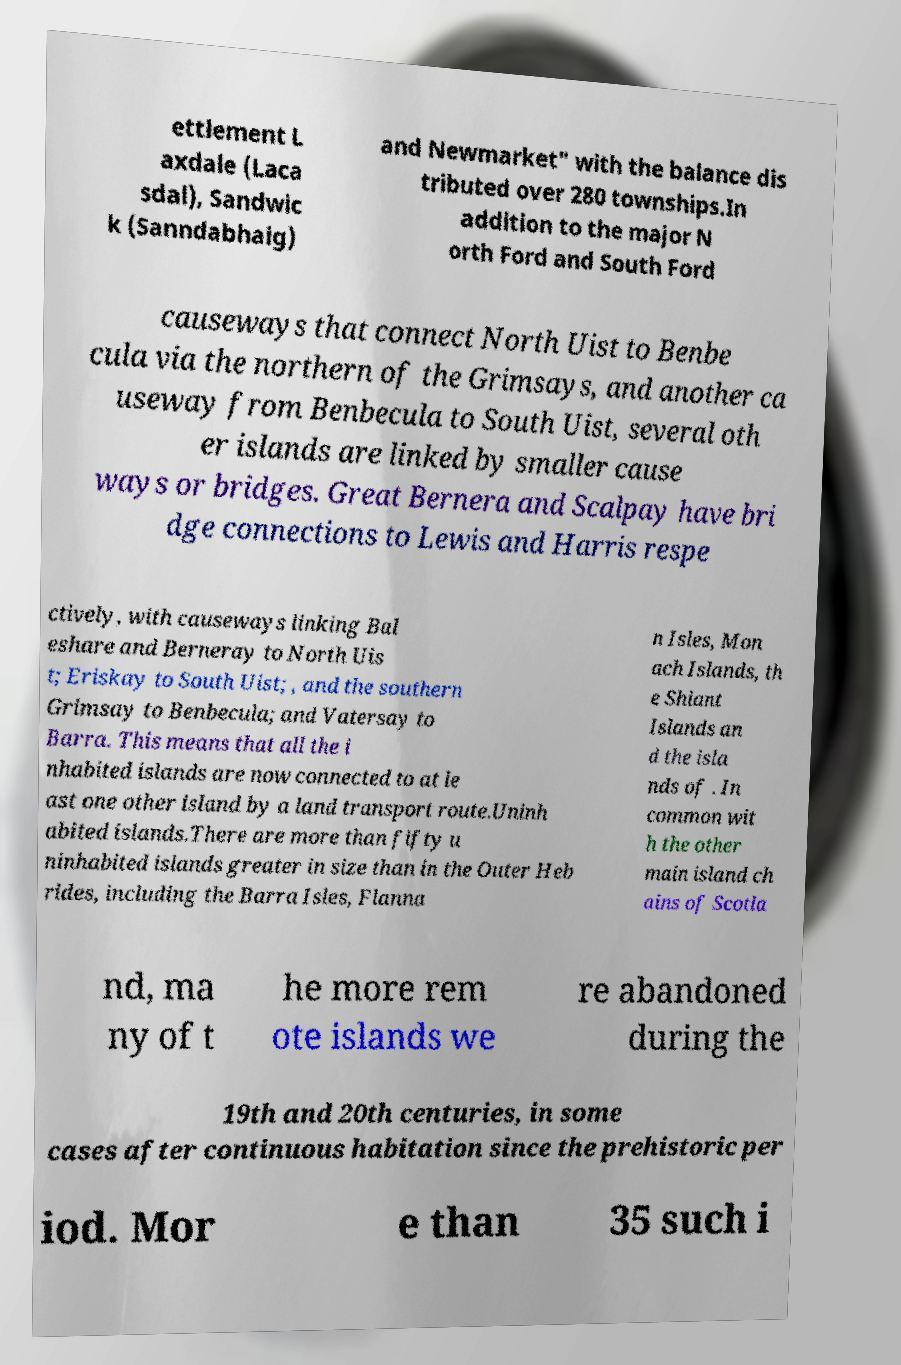Could you extract and type out the text from this image? ettlement L axdale (Laca sdal), Sandwic k (Sanndabhaig) and Newmarket" with the balance dis tributed over 280 townships.In addition to the major N orth Ford and South Ford causeways that connect North Uist to Benbe cula via the northern of the Grimsays, and another ca useway from Benbecula to South Uist, several oth er islands are linked by smaller cause ways or bridges. Great Bernera and Scalpay have bri dge connections to Lewis and Harris respe ctively, with causeways linking Bal eshare and Berneray to North Uis t; Eriskay to South Uist; , and the southern Grimsay to Benbecula; and Vatersay to Barra. This means that all the i nhabited islands are now connected to at le ast one other island by a land transport route.Uninh abited islands.There are more than fifty u ninhabited islands greater in size than in the Outer Heb rides, including the Barra Isles, Flanna n Isles, Mon ach Islands, th e Shiant Islands an d the isla nds of . In common wit h the other main island ch ains of Scotla nd, ma ny of t he more rem ote islands we re abandoned during the 19th and 20th centuries, in some cases after continuous habitation since the prehistoric per iod. Mor e than 35 such i 